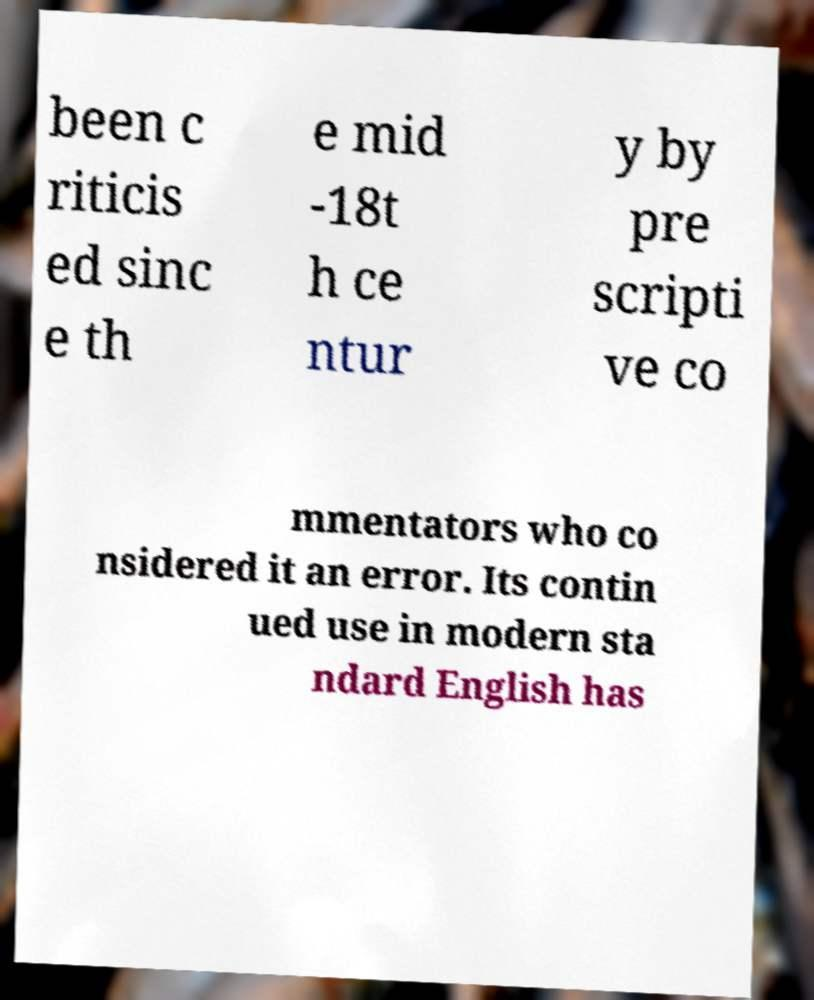There's text embedded in this image that I need extracted. Can you transcribe it verbatim? been c riticis ed sinc e th e mid -18t h ce ntur y by pre scripti ve co mmentators who co nsidered it an error. Its contin ued use in modern sta ndard English has 